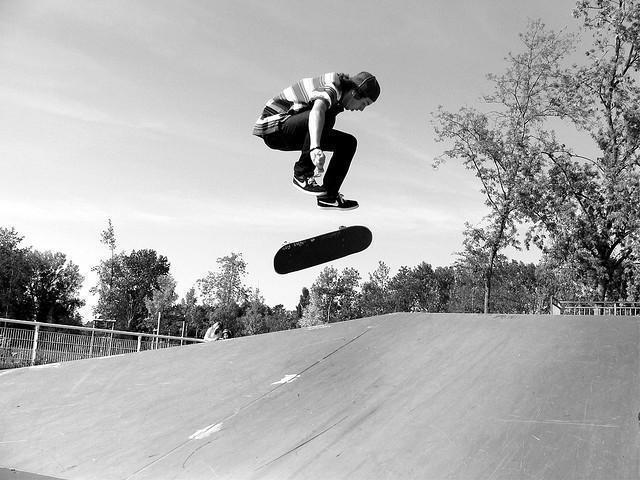What kind of shoes is the skater wearing?
Select the correct answer and articulate reasoning with the following format: 'Answer: answer
Rationale: rationale.'
Options: Vans, puma, airwalk, nike. Answer: nike.
Rationale: The nike logo is on the man's shoes. 